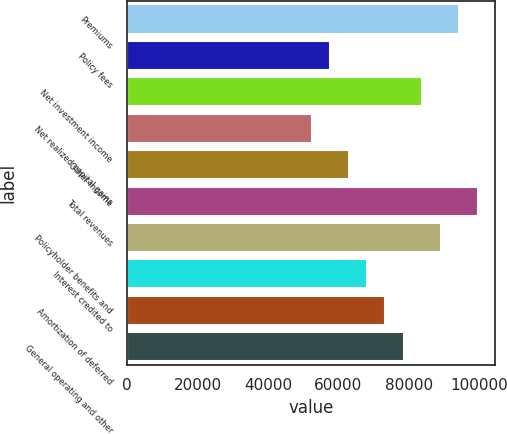<chart> <loc_0><loc_0><loc_500><loc_500><bar_chart><fcel>Premiums<fcel>Policy fees<fcel>Net investment income<fcel>Net realized capital gains<fcel>Other income<fcel>Total revenues<fcel>Policyholder benefits and<fcel>Interest credited to<fcel>Amortization of deferred<fcel>General operating and other<nl><fcel>94392.7<fcel>57684.9<fcel>83904.8<fcel>52441<fcel>62928.9<fcel>99636.7<fcel>89148.8<fcel>68172.9<fcel>73416.9<fcel>78660.8<nl></chart> 